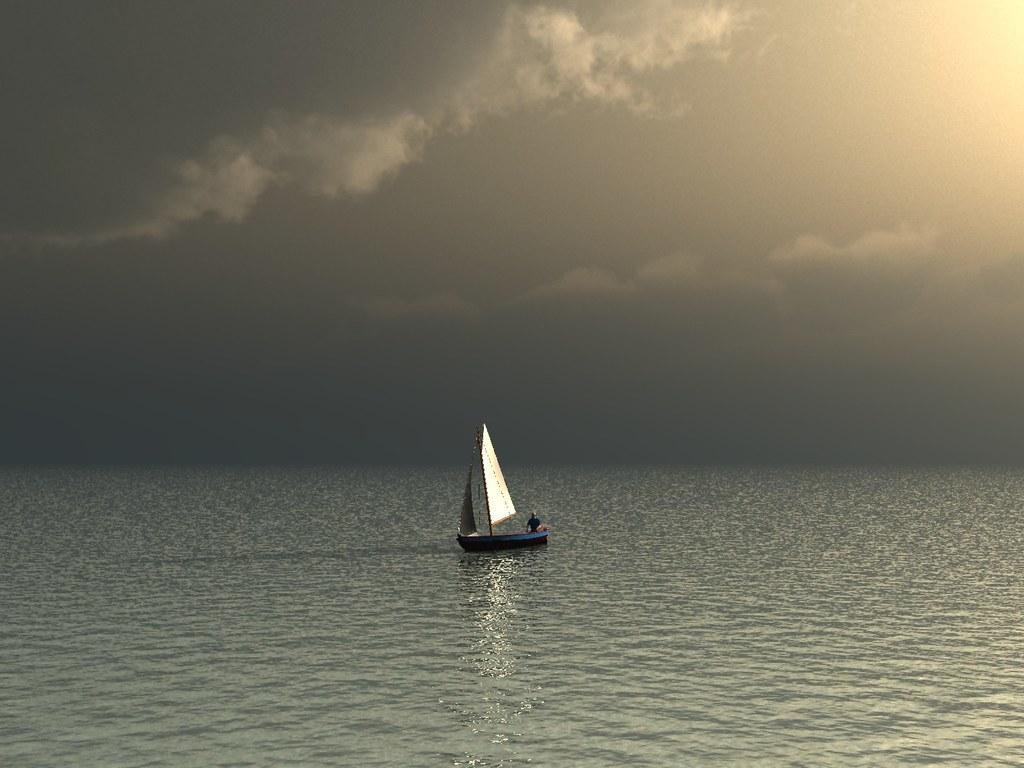In one or two sentences, can you explain what this image depicts? In this picture I can see the water in front and in the middle of this picture I see a boat and I see a person on it and in the background I see the sky which is cloudy. 